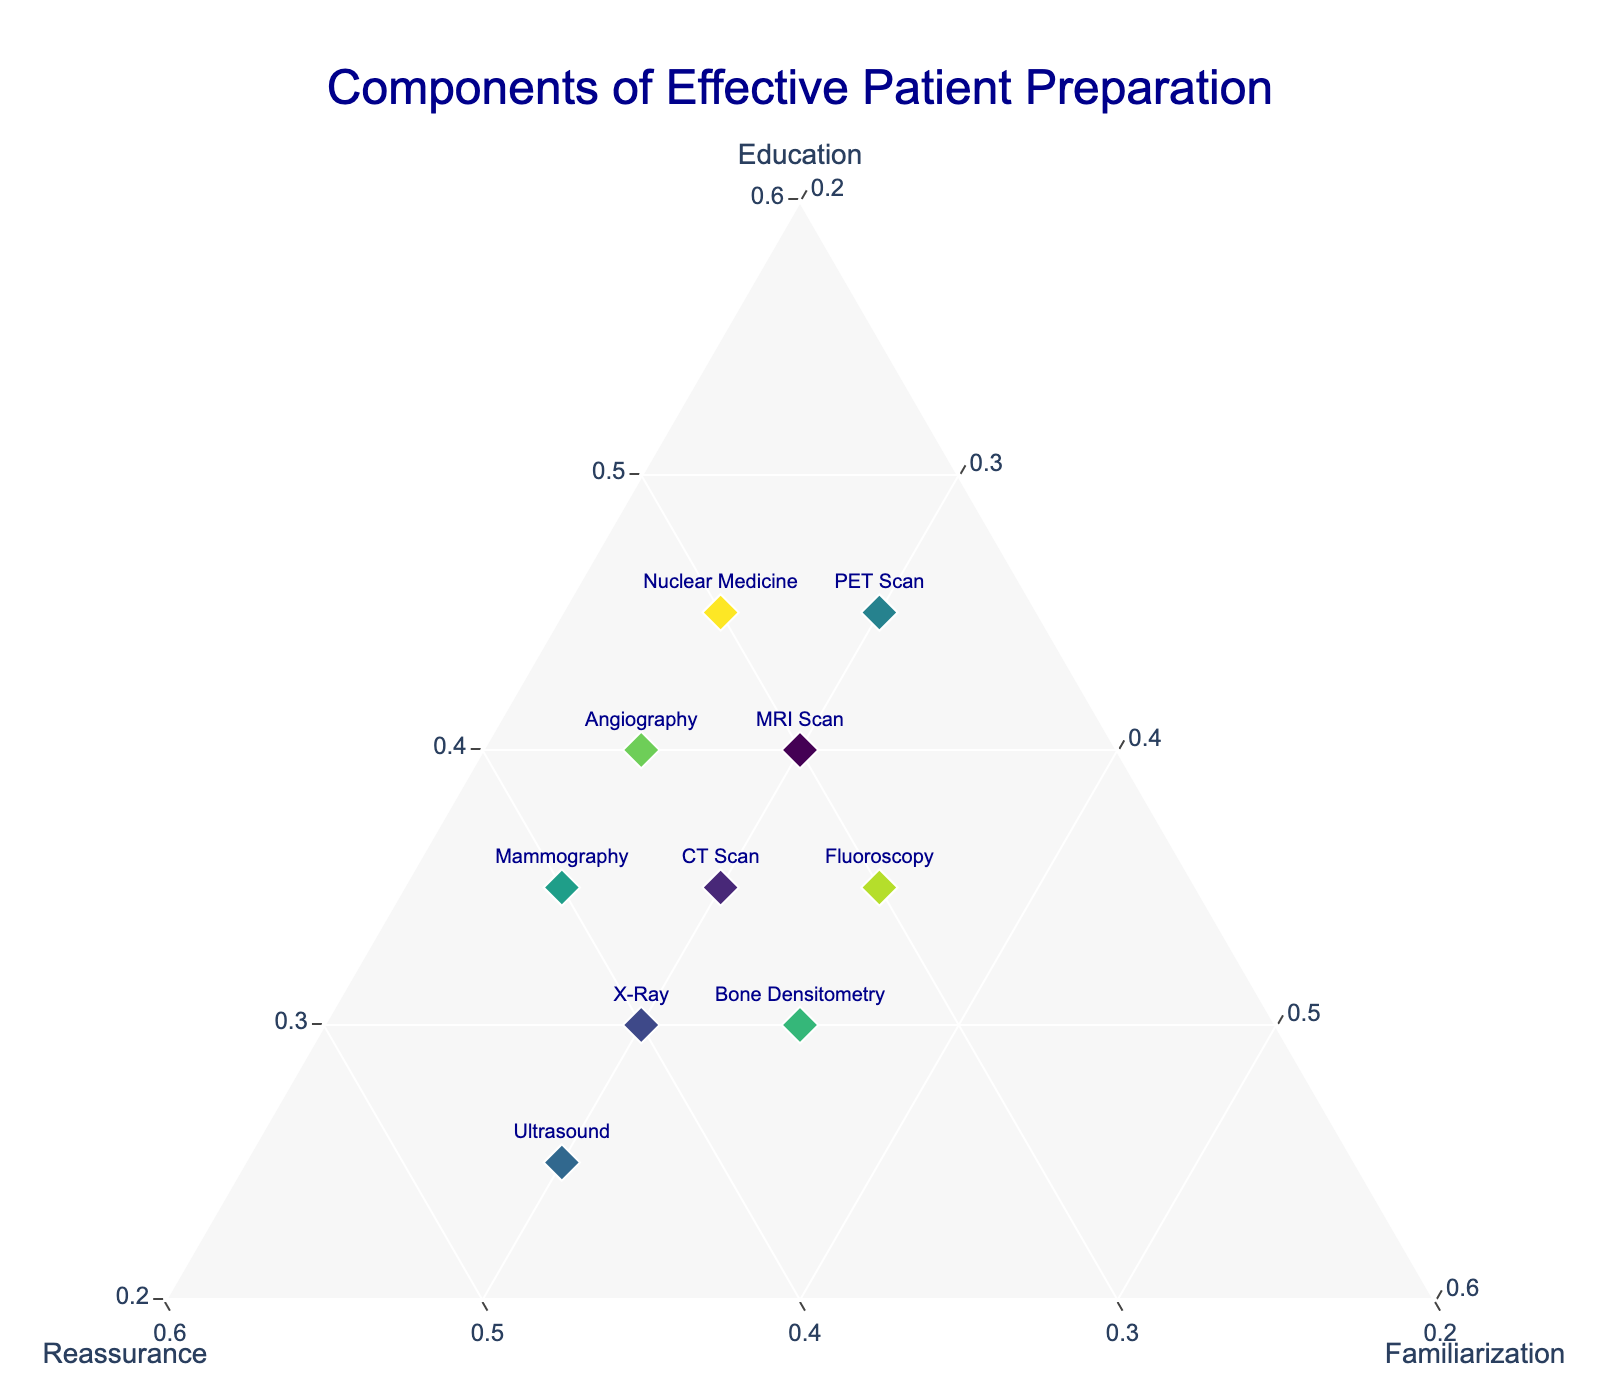What is the title of the plot? The title of the plot is usually placed at the top center area. In this case, the title is clearly provided in the figure.
Answer: Components of Effective Patient Preparation Which medical procedure places the highest emphasis on education? By looking for the point furthest along the 'Education' axis, we can see which procedure prioritizes education the most.
Answer: PET Scan and Nuclear Medicine How many procedures allocate exactly 0.3 to familiarization? By identifying all the points along the 'Familiarization' axis at the 0.3 mark, we can count the number of procedures.
Answer: 7 What is the sum of the proportions for each component in any given procedure? In a ternary plot, the sum of the proportions for education, reassurance, and familiarization will always equal 1.0 for any given procedure.
Answer: 1.0 Which procedure emphasizes reassurance the most? We need to find the procedure positioned closest to the 'Reassurance' vertex to determine which one places the most emphasis on reassurance.
Answer: Ultrasound Compare the proportions of education and reassurance for MRI and CT scans. Which one has a higher emphasis on reassurance? By examining the 'Reassurance' values for both MRI (0.3) and CT (0.35) scans, we compare these values directly.
Answer: CT Scan Which procedures have equal emphasis on reassurance and familiarization? By finding points along the line where the values of 'Reassurance' and 'Familiarization' are equal, we determine these procedures.
Answer: None Is there any procedure where familiarization is the highest component? Check if any of the data points are closest to the 'Familiarization' vertex, indicating it as the predominant component.
Answer: No For the Angiography procedure, which component is emphasized the least? By comparing the values for education (0.4), reassurance (0.35), and familiarization (0.25) for Angiography, we find the lowest value.
Answer: Familiarization What is the average proportion of education across all procedures? Summing the education values (0.4, 0.35, 0.3, 0.25, 0.45, 0.35, 0.3, 0.4, 0.35, 0.45) and dividing by the number of procedures (10) gives the average.
Answer: 0.36 